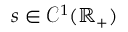<formula> <loc_0><loc_0><loc_500><loc_500>s \in \mathcal { C } ^ { 1 } ( \mathbb { R } _ { + } )</formula> 